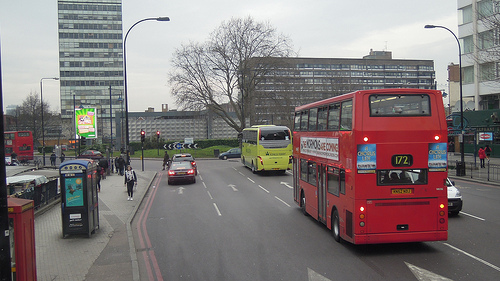<image>
Can you confirm if the building is next to the bus? No. The building is not positioned next to the bus. They are located in different areas of the scene. Is the booth in front of the person? Yes. The booth is positioned in front of the person, appearing closer to the camera viewpoint. 